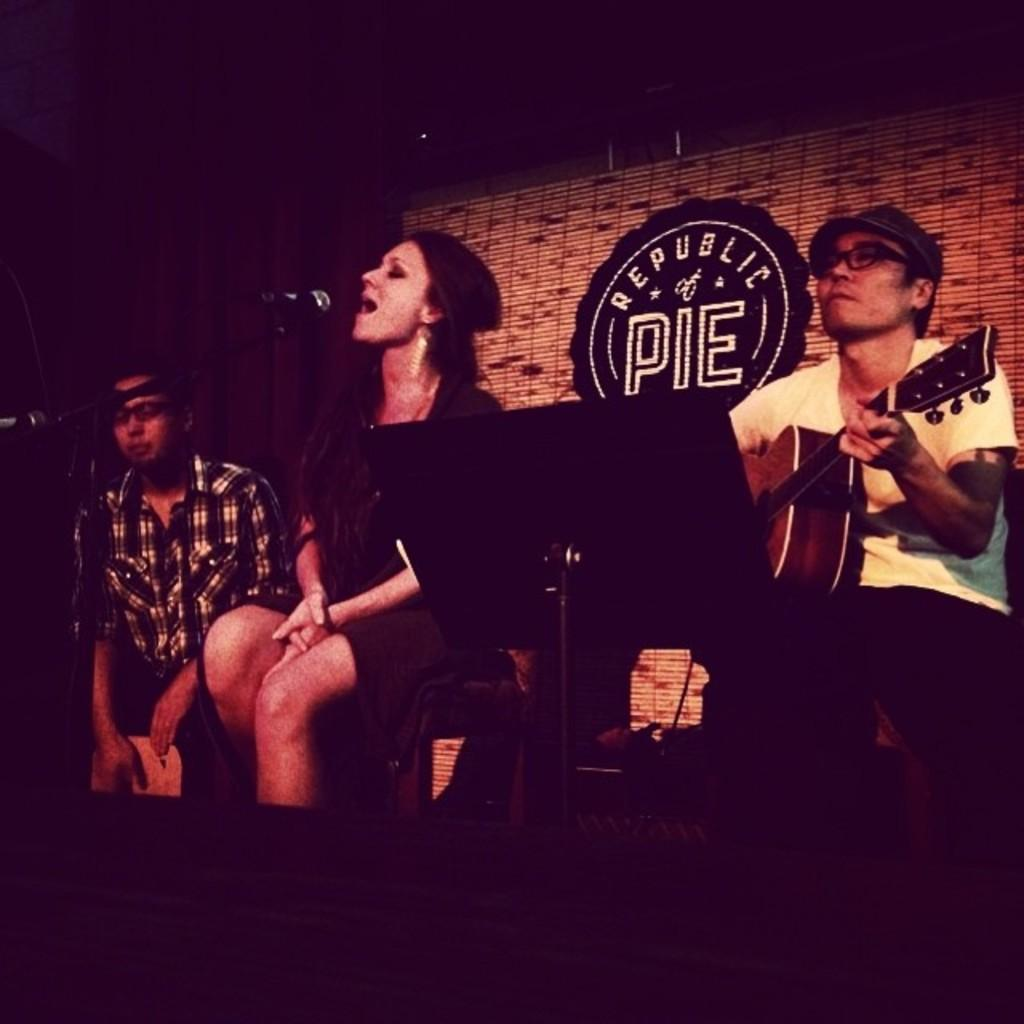What is the main setting of the image? There is a room in the image. What are the people in the room doing? Three people are sitting on chairs, and one person is playing a guitar on the right side of the room. A woman is in the center of the room, singing a song. How many people are actively participating in the musical performance? Two people are actively participating in the musical performance: one person is playing the guitar, and the woman is singing. Can you tell me how many times the woman sneezed during the song in the image? There is no indication in the image that the woman sneezed during the song. Is there a sink visible in the image? No, there is no sink present in the image. 